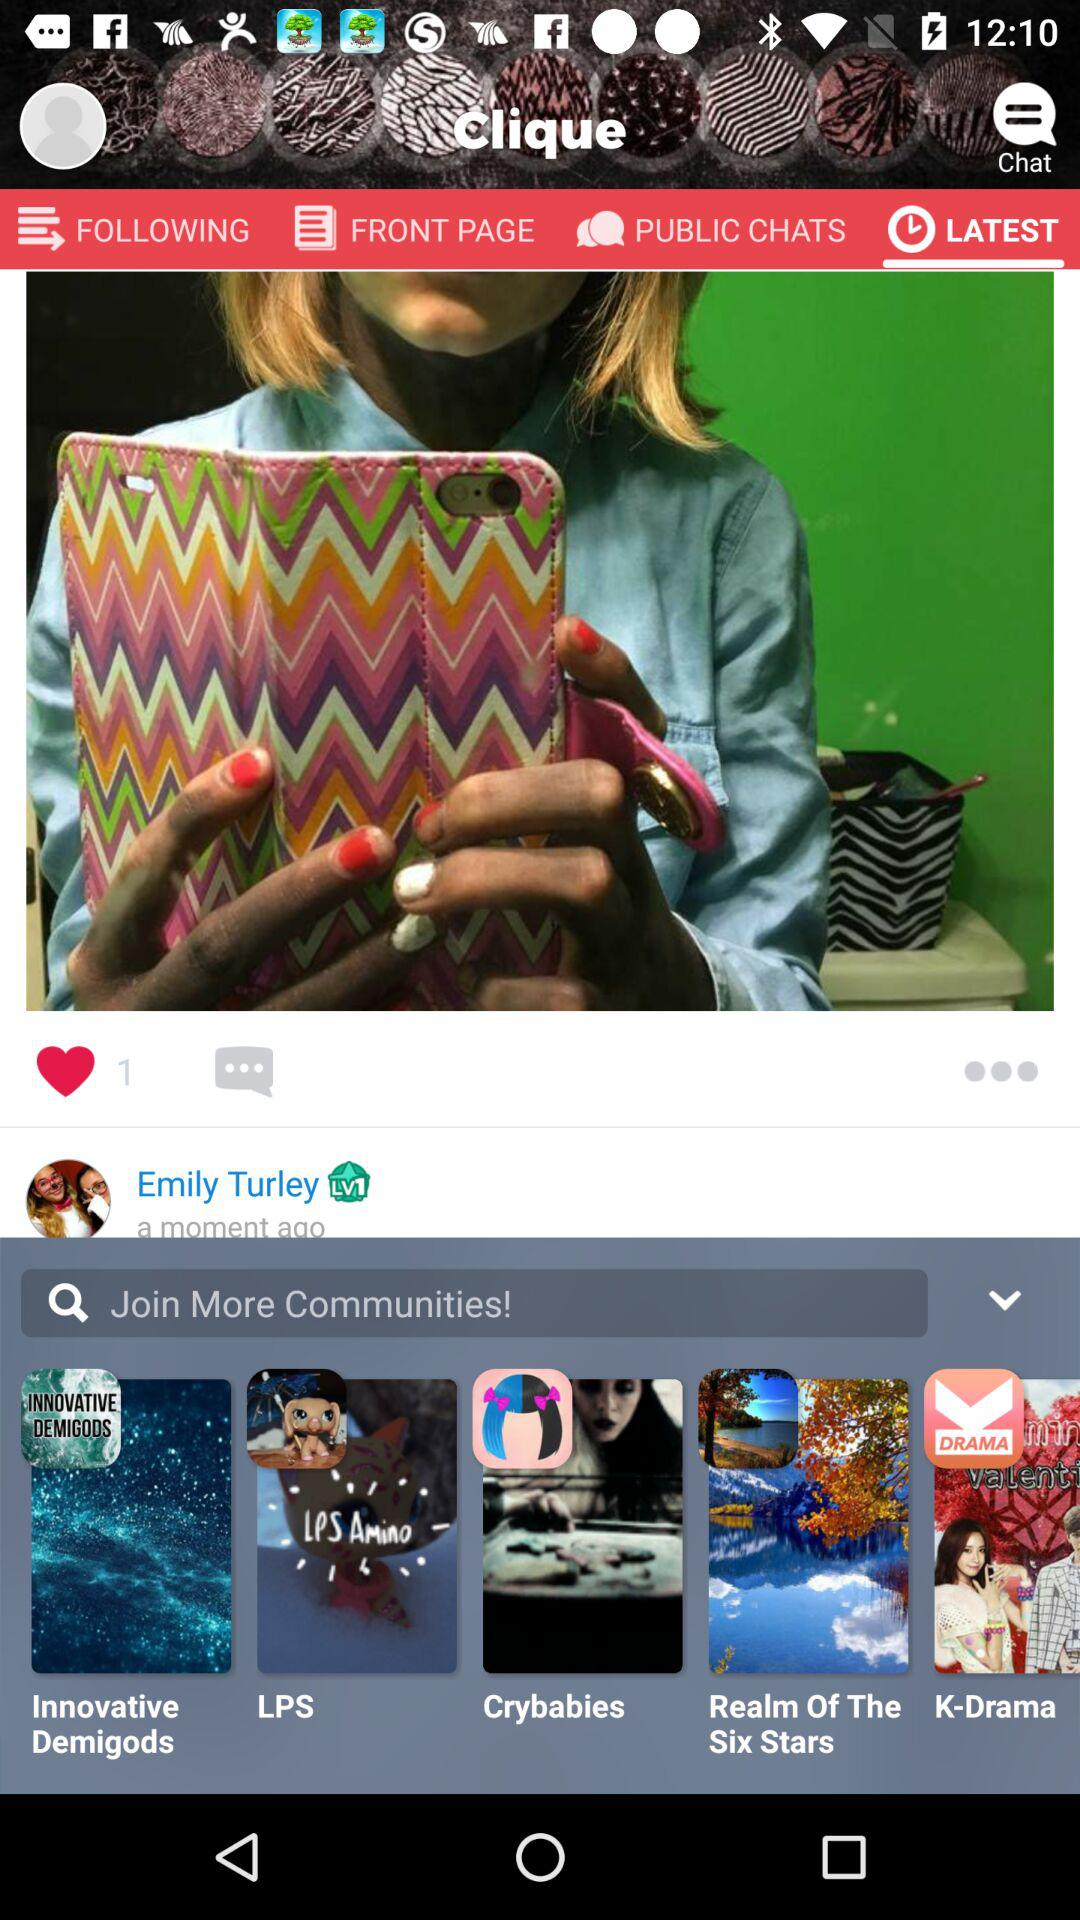What is the application name? The application name is "Clique". 